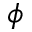Convert formula to latex. <formula><loc_0><loc_0><loc_500><loc_500>\phi</formula> 